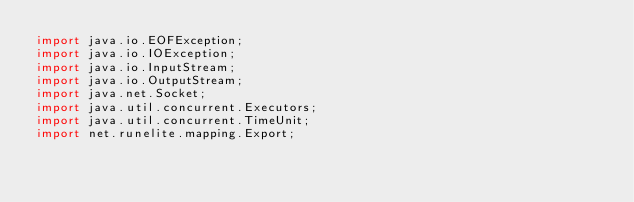<code> <loc_0><loc_0><loc_500><loc_500><_Java_>import java.io.EOFException;
import java.io.IOException;
import java.io.InputStream;
import java.io.OutputStream;
import java.net.Socket;
import java.util.concurrent.Executors;
import java.util.concurrent.TimeUnit;
import net.runelite.mapping.Export;</code> 